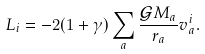<formula> <loc_0><loc_0><loc_500><loc_500>L _ { i } = - 2 ( 1 + \gamma ) \sum _ { a } \frac { \mathcal { G } M _ { a } } { r _ { a } } v ^ { i } _ { a } .</formula> 